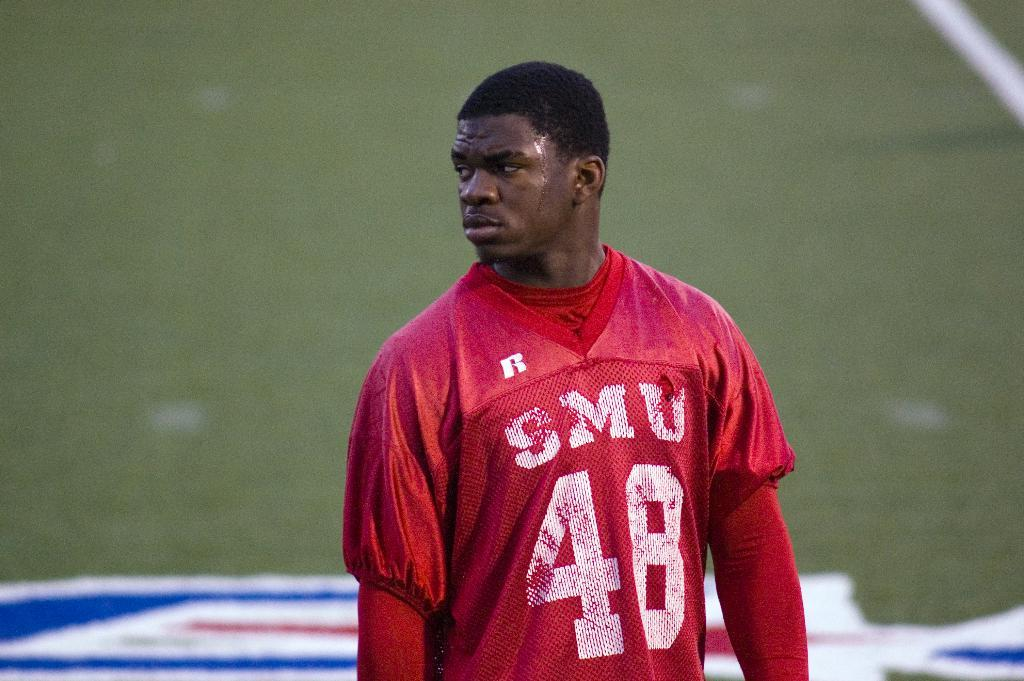<image>
Give a short and clear explanation of the subsequent image. a jersey that has the name of SMU on it 